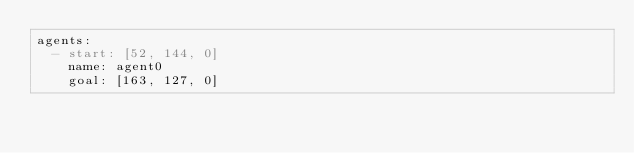<code> <loc_0><loc_0><loc_500><loc_500><_YAML_>agents:
  - start: [52, 144, 0]
    name: agent0
    goal: [163, 127, 0]</code> 